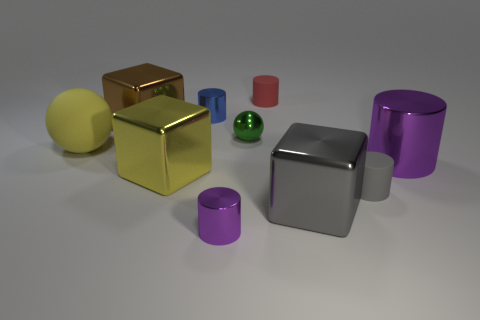How many other objects are there of the same color as the rubber ball?
Offer a terse response. 1. Does the purple cylinder on the left side of the big cylinder have the same material as the big yellow ball?
Make the answer very short. No. There is a object in front of the big gray cube; what is its material?
Offer a very short reply. Metal. There is a purple object that is on the left side of the tiny rubber cylinder behind the big brown metal cube; what size is it?
Ensure brevity in your answer.  Small. What number of other rubber objects are the same size as the gray rubber thing?
Keep it short and to the point. 1. There is a cube that is right of the metallic ball; does it have the same color as the big object that is behind the big yellow matte thing?
Your answer should be compact. No. There is a blue thing; are there any large brown metallic objects to the right of it?
Your answer should be compact. No. What is the color of the rubber object that is behind the big purple metal cylinder and right of the large yellow ball?
Give a very brief answer. Red. Are there any spheres of the same color as the large cylinder?
Ensure brevity in your answer.  No. Do the purple cylinder that is on the left side of the green ball and the big yellow thing that is behind the large purple object have the same material?
Your answer should be very brief. No. 